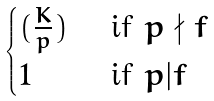Convert formula to latex. <formula><loc_0><loc_0><loc_500><loc_500>\begin{cases} ( \frac { K } { p } ) & \text { if } p \nmid f \\ 1 & \text { if } p | f \end{cases}</formula> 